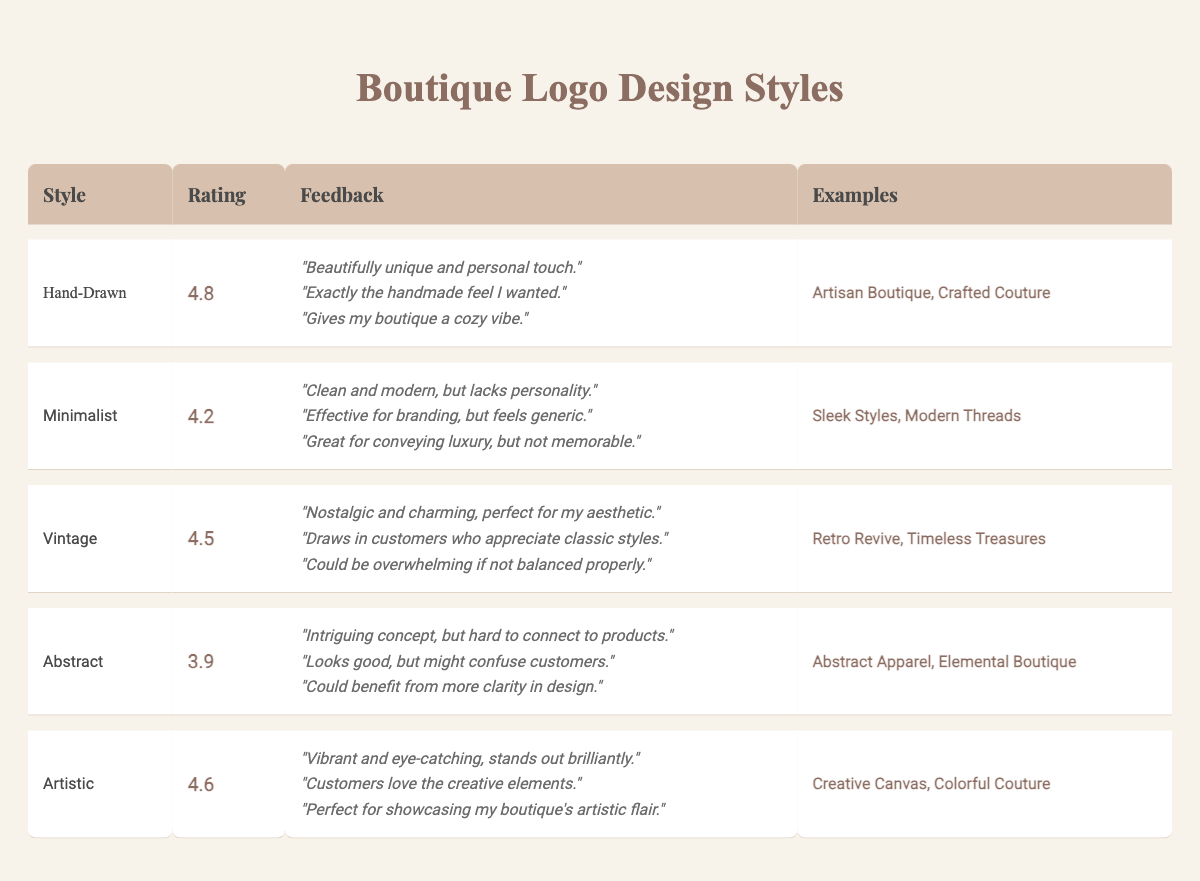What is the highest customer feedback rating among the logo styles? The highest rating in the table is 4.8, associated with the Hand-Drawn style.
Answer: 4.8 Which logo style has the lowest rating? The Abstract logo style has the lowest rating of 3.9, as per the customer feedback.
Answer: Abstract How many examples are provided for the Vintage logo style? There are two examples listed for the Vintage logo style: Retro Revive and Timeless Treasures.
Answer: 2 What is the average rating of the logo styles listed in the table? Adding the ratings: 4.8 + 4.2 + 4.5 + 3.9 + 4.6 = 22.0. Dividing by the number of styles (5) gives 22.0 / 5 = 4.4.
Answer: 4.4 Are customers more satisfied with the Hand-Drawn style compared to the Minimalist style? The Hand-Drawn style has a rating of 4.8, while the Minimalist style has a rating of 4.2, indicating higher satisfaction with Hand-Drawn.
Answer: Yes List the styles that have ratings greater than 4.5. The Hand-Drawn (4.8), Vintage (4.5), and Artistic (4.6) styles have ratings greater than 4.5.
Answer: Hand-Drawn, Artistic How many comments are provided for the Artistic logo style? There are three comments listed under the Artistic logo style, indicating specific feedback from customers.
Answer: 3 Which style is described with a rating of 4.6? The Artistic logo style is associated with a customer feedback rating of 4.6.
Answer: Artistic What feedback theme is common in the comments for the Hand-Drawn style? The comments highlight a unique and personal touch as a common theme in customer feedback for the Hand-Drawn style.
Answer: Unique and personal touch If you consider only the logo styles with a rating below 4.0, how many styles are there? Only the Abstract style has a rating below 4.0 (3.9), making it the only one in this category.
Answer: 1 